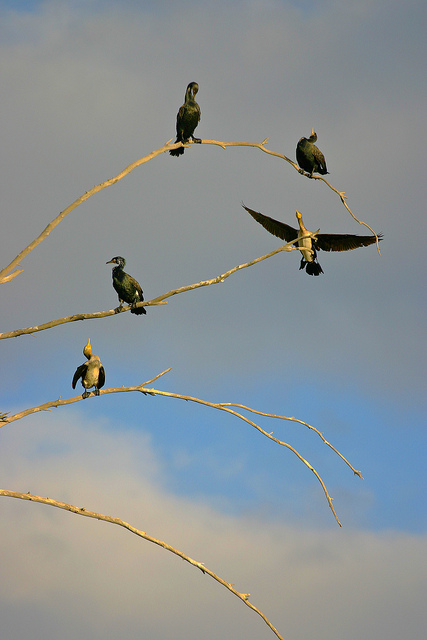Can you describe the habitat in which these birds are found? These birds are typically found in aquatic or near-aquatic environments, where the branches they perch on often protrude from bodies of water. 